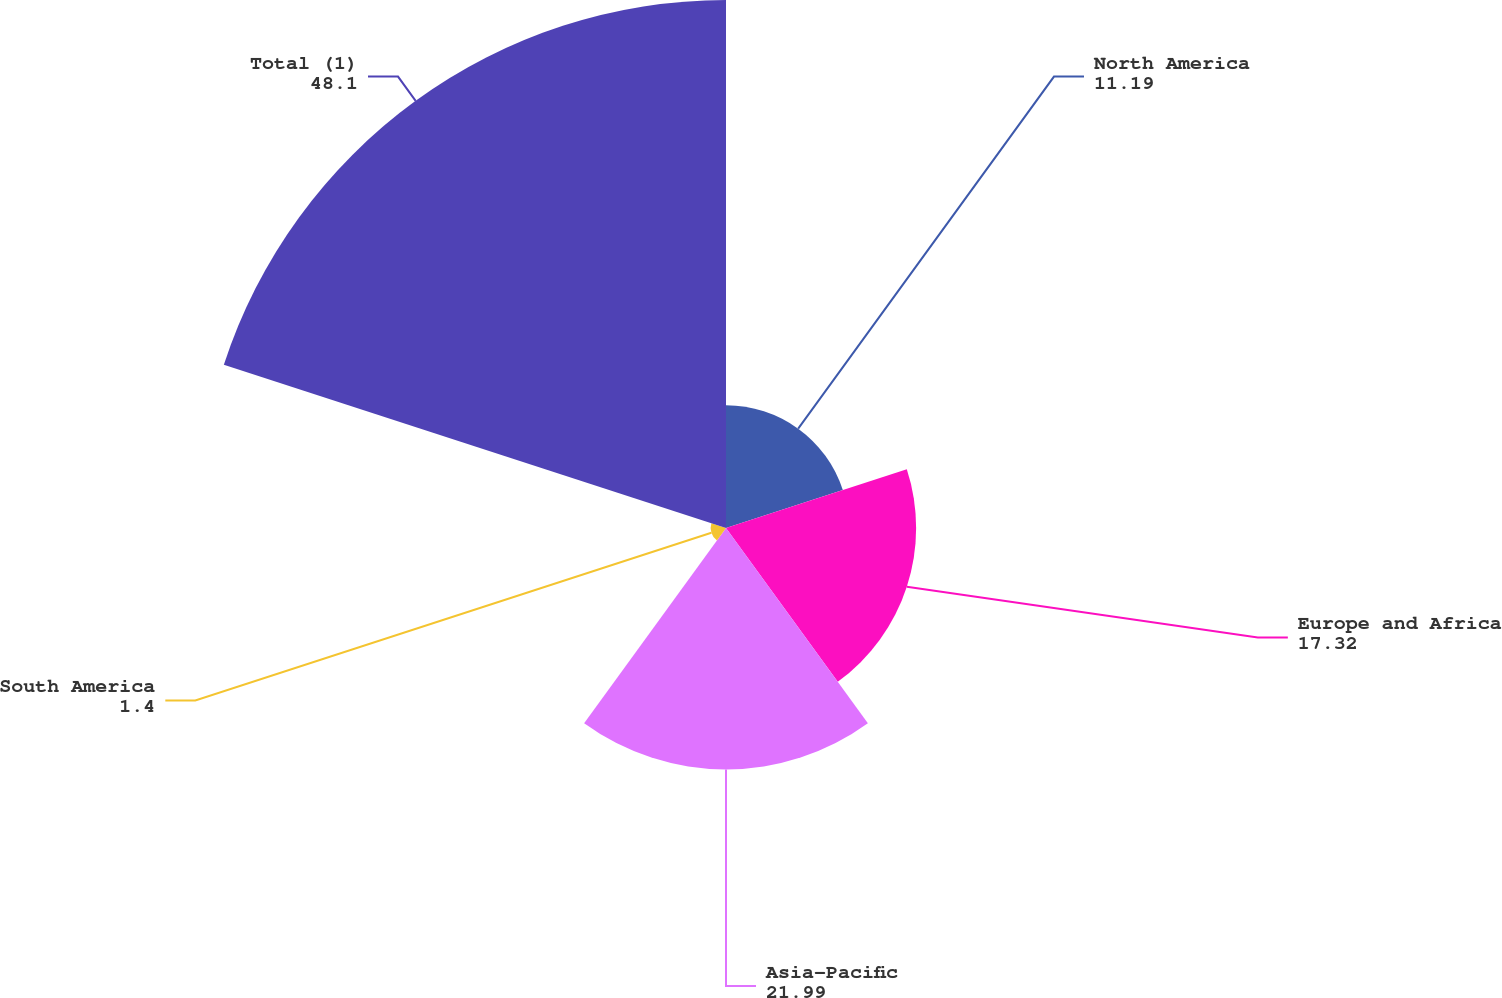Convert chart. <chart><loc_0><loc_0><loc_500><loc_500><pie_chart><fcel>North America<fcel>Europe and Africa<fcel>Asia-Pacific<fcel>South America<fcel>Total (1)<nl><fcel>11.19%<fcel>17.32%<fcel>21.99%<fcel>1.4%<fcel>48.1%<nl></chart> 